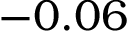Convert formula to latex. <formula><loc_0><loc_0><loc_500><loc_500>- 0 . 0 6</formula> 